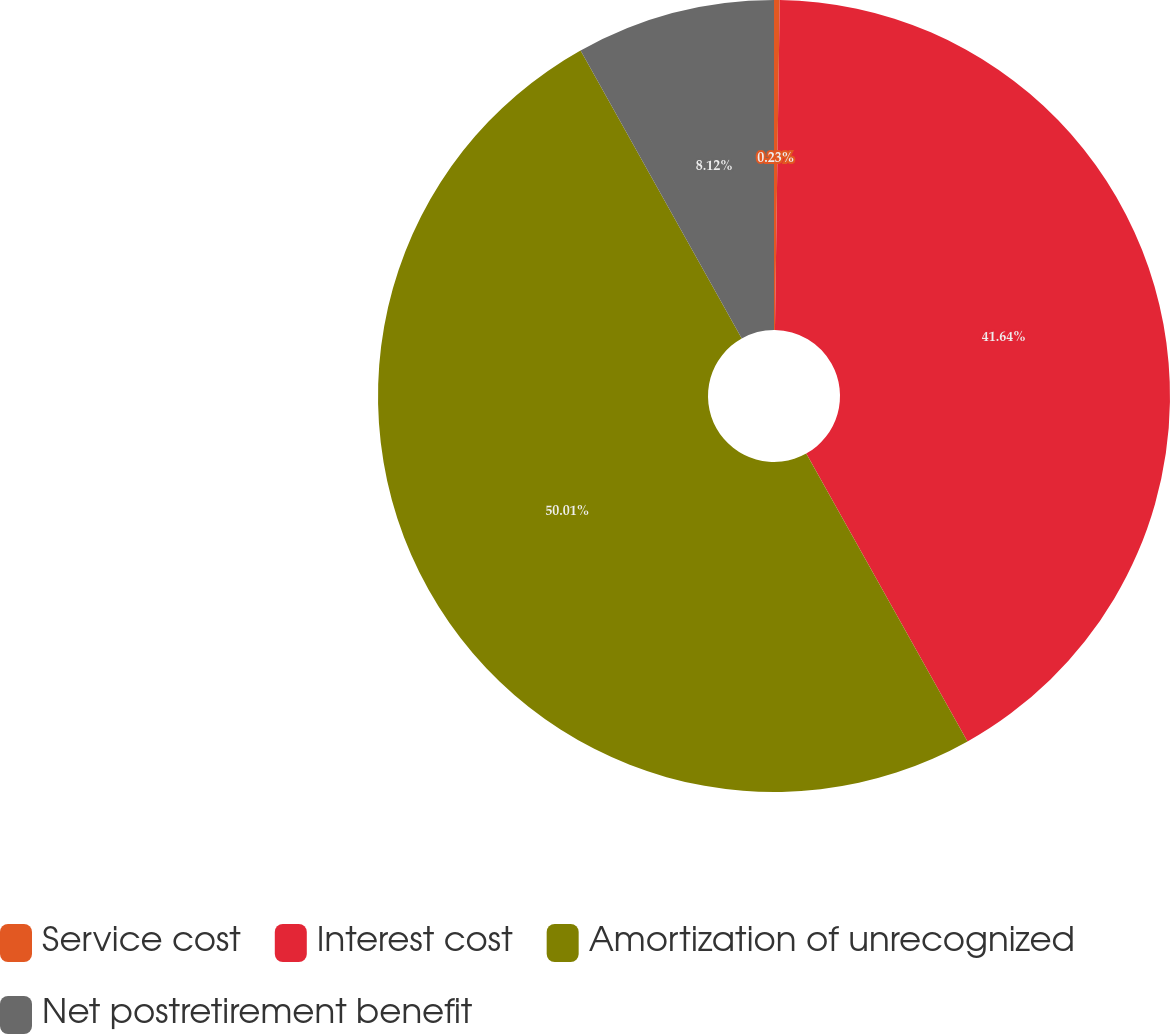<chart> <loc_0><loc_0><loc_500><loc_500><pie_chart><fcel>Service cost<fcel>Interest cost<fcel>Amortization of unrecognized<fcel>Net postretirement benefit<nl><fcel>0.23%<fcel>41.64%<fcel>50.0%<fcel>8.12%<nl></chart> 